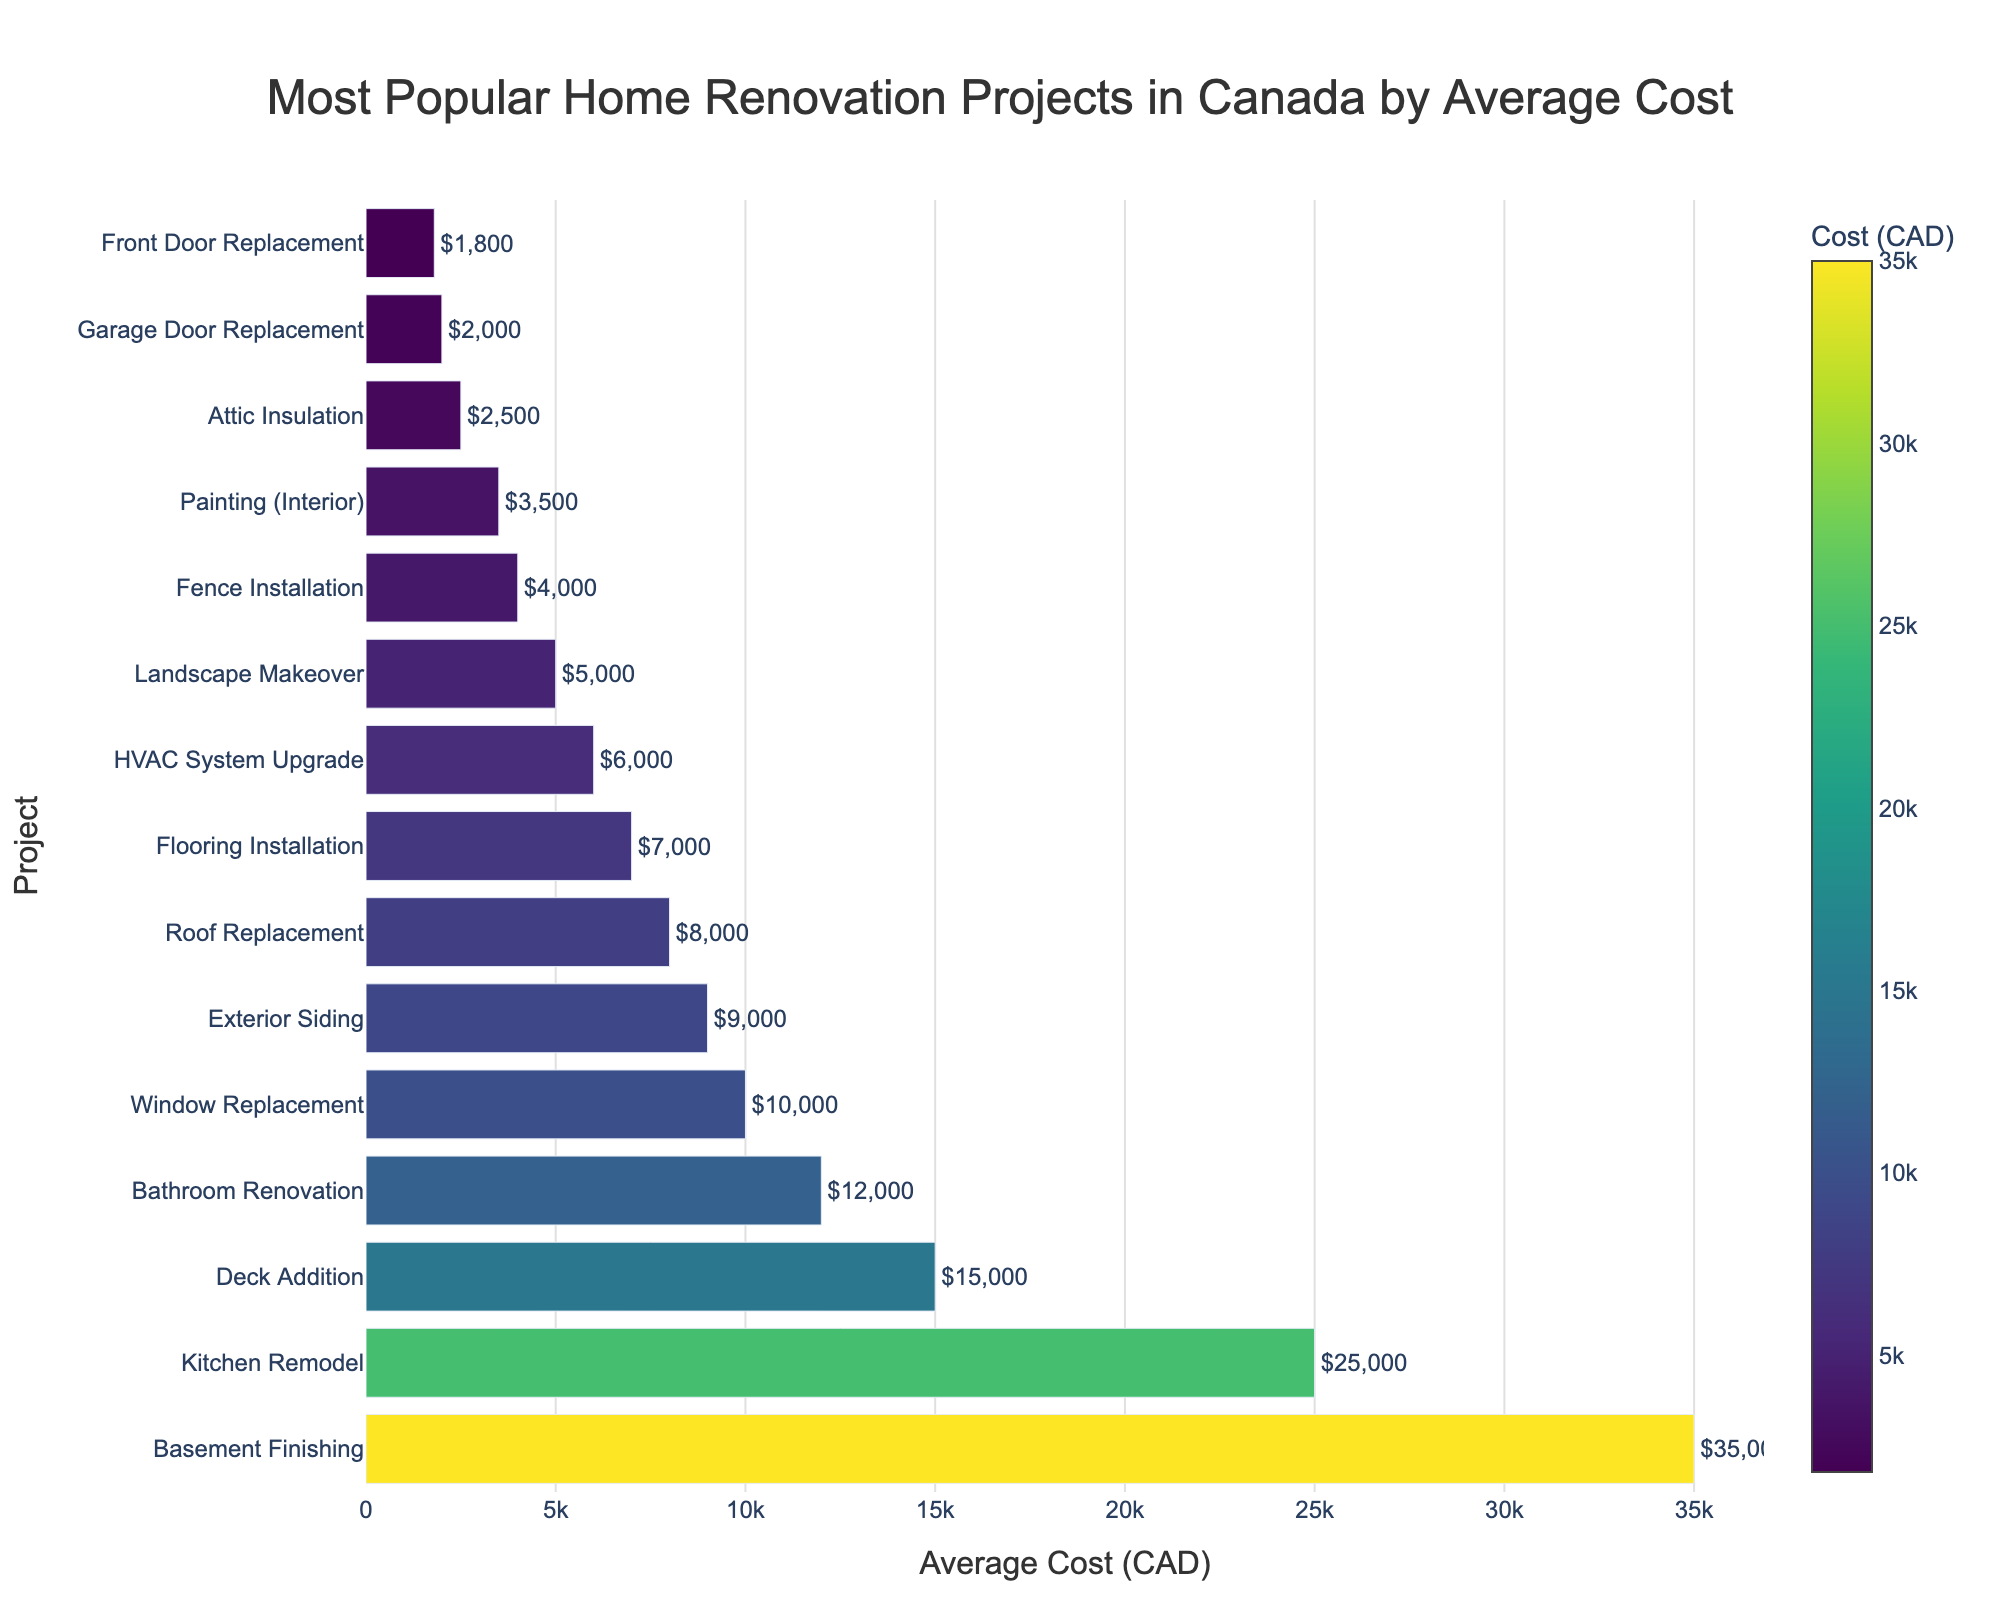What is the most expensive renovation project? Look at the bar that is the longest since it represents the highest cost. The "Basement Finishing" project has the longest bar, indicating it has the highest cost.
Answer: Basement Finishing Which renovation project has the lowest average cost? Look at the bar that is the shortest as it represents the lowest cost. The "Front Door Replacement" project has the shortest bar, indicating it has the lowest cost.
Answer: Front Door Replacement What is the difference in average cost between a Kitchen Remodel and a Bathroom Renovation? Find the cost of "Kitchen Remodel" and "Bathroom Renovation" from the bars. "Kitchen Remodel" is $25,000 and "Bathroom Renovation" is $12,000. Subtract the smaller from the larger: 25,000 - 12,000 = 13,000
Answer: 13,000 Which project is more expensive: Roof Replacement or Deck Addition? Compare the lengths of the bars for "Roof Replacement" and "Deck Addition." The bar for "Deck Addition" is longer, indicating it is more expensive.
Answer: Deck Addition What is the combined cost of Attic Insulation, Garage Door Replacement, and Painting (Interior)? Find the costs of "Attic Insulation" ($2,500), "Garage Door Replacement" ($2,000), and "Painting (Interior)" ($3,500). Add them: 2,500 + 2,000 + 3,500 = 8,000
Answer: 8,000 Which projects have an average cost greater than $10,000? Identify and list the projects with bars extending beyond the $10,000 mark. They are "Kitchen Remodel," "Bathroom Renovation," "Basement Finishing," and "Deck Addition."
Answer: Kitchen Remodel, Bathroom Renovation, Basement Finishing, Deck Addition What is the average cost of the top three most expensive projects? The top three most expensive projects by bar length are "Basement Finishing" ($35,000), "Kitchen Remodel" ($25,000), and "Deck Addition" ($15,000). Calculate their average: (35,000 + 25,000 + 15,000) / 3 = 25,000
Answer: 25,000 How much more costly is Flooring Installation compared to Fence Installation? Find the difference between "Flooring Installation" ($7,000) and "Fence Installation" ($4,000): 7,000 - 4,000 = 3,000
Answer: 3,000 Which project has a cost closest to $10,000? Find the bar whose end is closest to the $10,000 mark. "Window Replacement" has an average cost exactly at $10,000.
Answer: Window Replacement Between Landscape Makeover and HVAC System Upgrade, which is cheaper and by how much? Compare the costs of "Landscape Makeover" ($5,000) and "HVAC System Upgrade" ($6,000). Subtract the smaller from the larger: 6,000 - 5,000 = 1,000. So, "Landscape Makeover" is cheaper.
Answer: Landscape Makeover by 1,000 